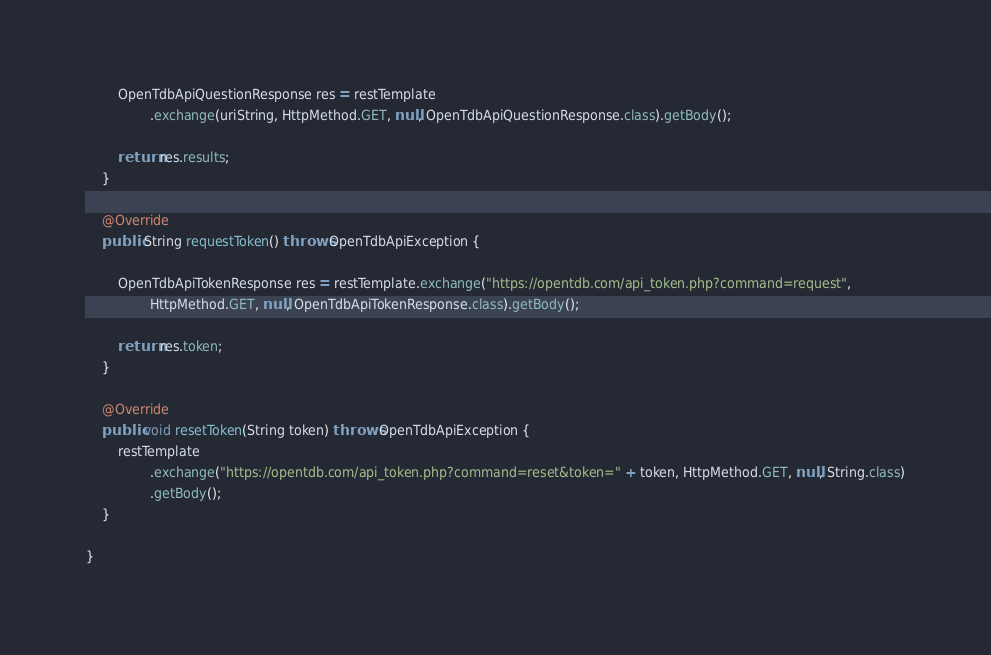<code> <loc_0><loc_0><loc_500><loc_500><_Java_>		OpenTdbApiQuestionResponse res = restTemplate
				.exchange(uriString, HttpMethod.GET, null, OpenTdbApiQuestionResponse.class).getBody();

		return res.results;
	}

	@Override
	public String requestToken() throws OpenTdbApiException {

		OpenTdbApiTokenResponse res = restTemplate.exchange("https://opentdb.com/api_token.php?command=request",
				HttpMethod.GET, null, OpenTdbApiTokenResponse.class).getBody();

		return res.token;
	}

	@Override
	public void resetToken(String token) throws OpenTdbApiException {
		restTemplate
				.exchange("https://opentdb.com/api_token.php?command=reset&token=" + token, HttpMethod.GET, null, String.class)
				.getBody();
	}

}
</code> 